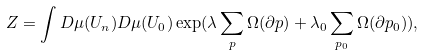<formula> <loc_0><loc_0><loc_500><loc_500>Z = \int D \mu ( U _ { n } ) D \mu ( U _ { 0 } ) \exp ( \lambda \sum _ { p } \Omega ( \partial p ) + \lambda _ { 0 } \sum _ { p _ { 0 } } \Omega ( \partial p _ { 0 } ) ) ,</formula> 